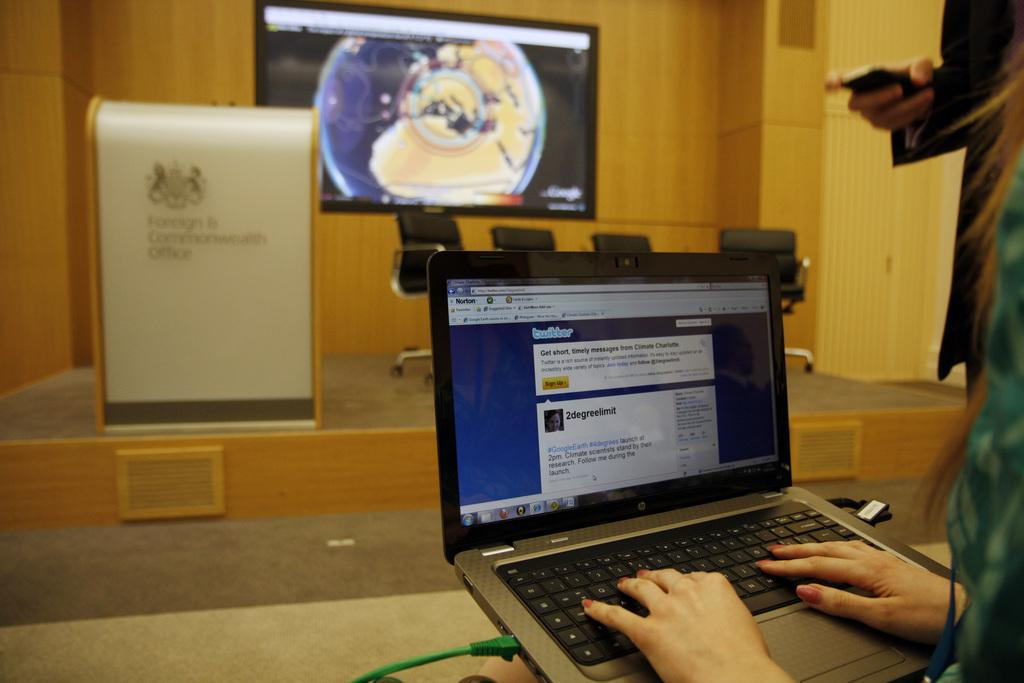<image>
Write a terse but informative summary of the picture. A computer monitor is on twitter and is looking at a post from 2degreelimit 